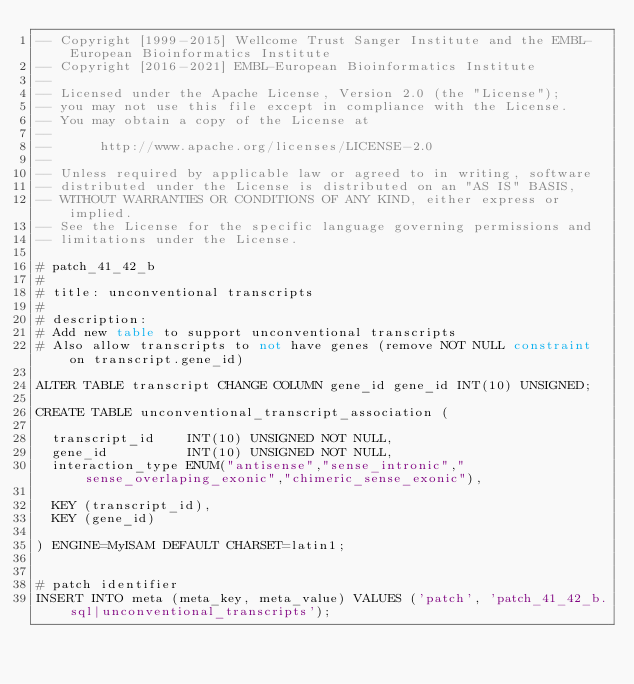Convert code to text. <code><loc_0><loc_0><loc_500><loc_500><_SQL_>-- Copyright [1999-2015] Wellcome Trust Sanger Institute and the EMBL-European Bioinformatics Institute
-- Copyright [2016-2021] EMBL-European Bioinformatics Institute
-- 
-- Licensed under the Apache License, Version 2.0 (the "License");
-- you may not use this file except in compliance with the License.
-- You may obtain a copy of the License at
-- 
--      http://www.apache.org/licenses/LICENSE-2.0
-- 
-- Unless required by applicable law or agreed to in writing, software
-- distributed under the License is distributed on an "AS IS" BASIS,
-- WITHOUT WARRANTIES OR CONDITIONS OF ANY KIND, either express or implied.
-- See the License for the specific language governing permissions and
-- limitations under the License.

# patch_41_42_b
#
# title: unconventional transcripts
#
# description:
# Add new table to support unconventional transcripts
# Also allow transcripts to not have genes (remove NOT NULL constraint on transcript.gene_id)

ALTER TABLE transcript CHANGE COLUMN gene_id gene_id INT(10) UNSIGNED;

CREATE TABLE unconventional_transcript_association (

  transcript_id    INT(10) UNSIGNED NOT NULL,
  gene_id          INT(10) UNSIGNED NOT NULL,
  interaction_type ENUM("antisense","sense_intronic","sense_overlaping_exonic","chimeric_sense_exonic"),

  KEY (transcript_id),
  KEY (gene_id)

) ENGINE=MyISAM DEFAULT CHARSET=latin1;


# patch identifier
INSERT INTO meta (meta_key, meta_value) VALUES ('patch', 'patch_41_42_b.sql|unconventional_transcripts');
</code> 